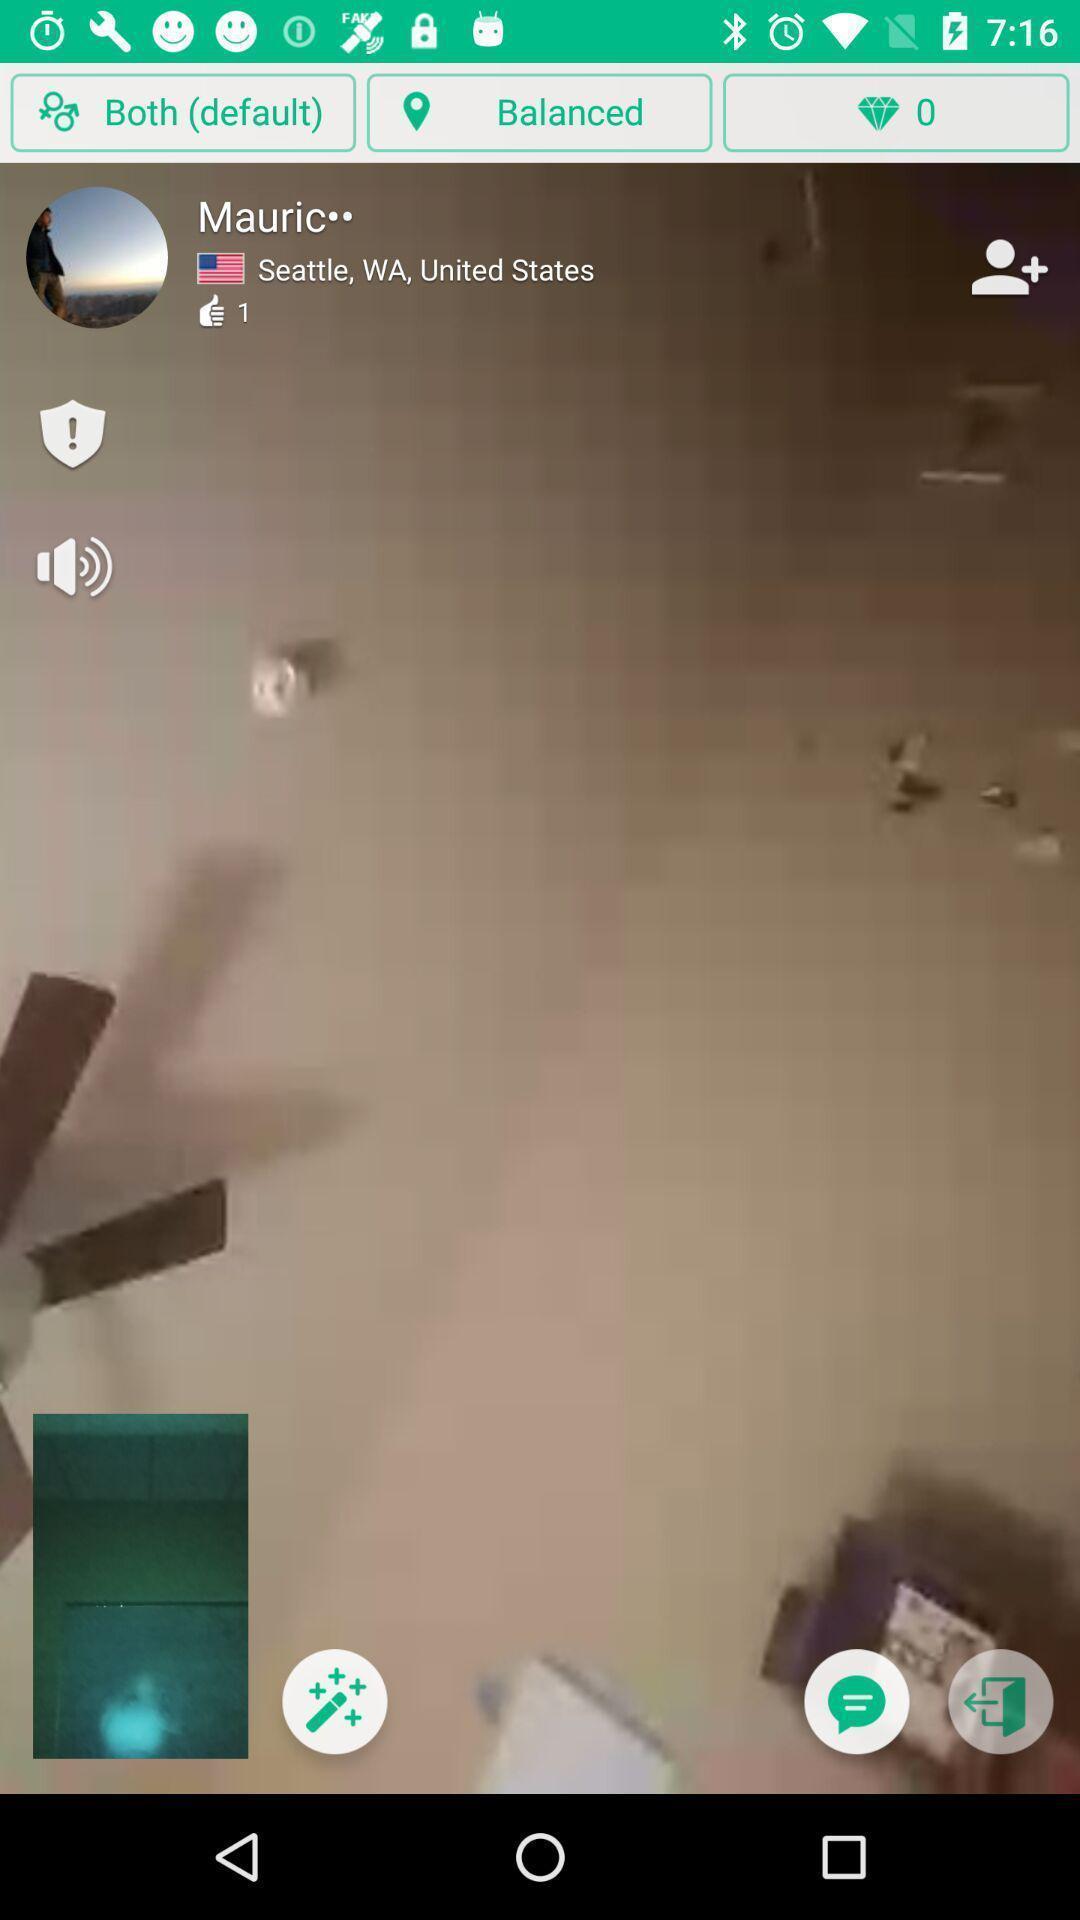Explain the elements present in this screenshot. Video call page in a friend making app. 